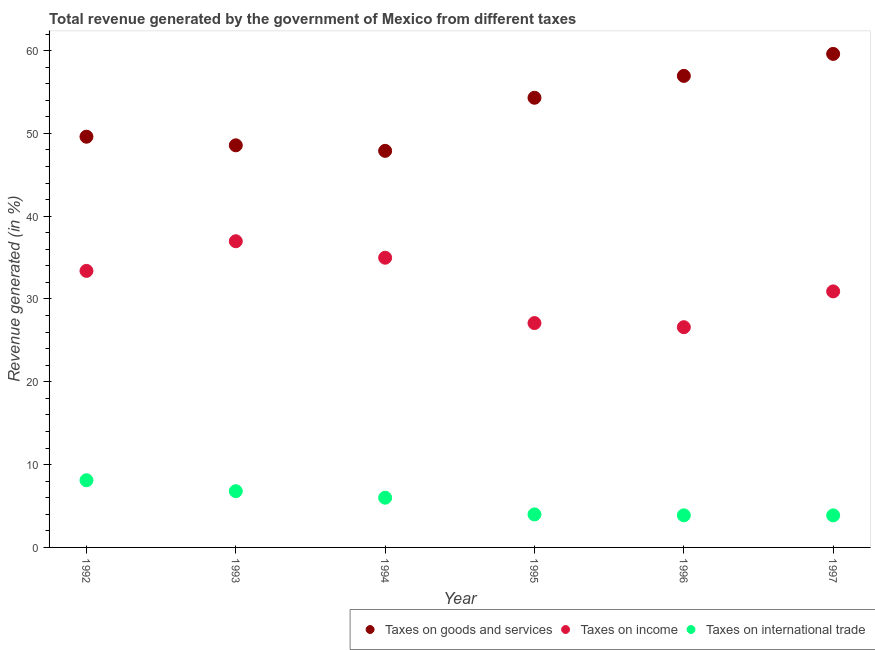How many different coloured dotlines are there?
Provide a succinct answer. 3. Is the number of dotlines equal to the number of legend labels?
Your answer should be very brief. Yes. What is the percentage of revenue generated by tax on international trade in 1995?
Keep it short and to the point. 3.99. Across all years, what is the maximum percentage of revenue generated by taxes on income?
Provide a short and direct response. 36.97. Across all years, what is the minimum percentage of revenue generated by tax on international trade?
Provide a short and direct response. 3.87. In which year was the percentage of revenue generated by taxes on goods and services maximum?
Make the answer very short. 1997. In which year was the percentage of revenue generated by taxes on income minimum?
Ensure brevity in your answer.  1996. What is the total percentage of revenue generated by taxes on goods and services in the graph?
Keep it short and to the point. 316.88. What is the difference between the percentage of revenue generated by tax on international trade in 1992 and that in 1993?
Your response must be concise. 1.32. What is the difference between the percentage of revenue generated by taxes on goods and services in 1994 and the percentage of revenue generated by tax on international trade in 1993?
Provide a short and direct response. 41.1. What is the average percentage of revenue generated by tax on international trade per year?
Your answer should be compact. 5.44. In the year 1992, what is the difference between the percentage of revenue generated by tax on international trade and percentage of revenue generated by taxes on goods and services?
Make the answer very short. -41.49. What is the ratio of the percentage of revenue generated by tax on international trade in 1995 to that in 1996?
Give a very brief answer. 1.03. What is the difference between the highest and the second highest percentage of revenue generated by tax on international trade?
Keep it short and to the point. 1.32. What is the difference between the highest and the lowest percentage of revenue generated by taxes on goods and services?
Your answer should be compact. 11.71. Is it the case that in every year, the sum of the percentage of revenue generated by taxes on goods and services and percentage of revenue generated by taxes on income is greater than the percentage of revenue generated by tax on international trade?
Your answer should be compact. Yes. Is the percentage of revenue generated by tax on international trade strictly greater than the percentage of revenue generated by taxes on income over the years?
Offer a very short reply. No. Is the percentage of revenue generated by taxes on goods and services strictly less than the percentage of revenue generated by tax on international trade over the years?
Your answer should be very brief. No. What is the difference between two consecutive major ticks on the Y-axis?
Offer a terse response. 10. Where does the legend appear in the graph?
Provide a succinct answer. Bottom right. How are the legend labels stacked?
Your answer should be compact. Horizontal. What is the title of the graph?
Provide a short and direct response. Total revenue generated by the government of Mexico from different taxes. Does "Primary" appear as one of the legend labels in the graph?
Keep it short and to the point. No. What is the label or title of the X-axis?
Provide a succinct answer. Year. What is the label or title of the Y-axis?
Your answer should be very brief. Revenue generated (in %). What is the Revenue generated (in %) in Taxes on goods and services in 1992?
Ensure brevity in your answer.  49.6. What is the Revenue generated (in %) in Taxes on income in 1992?
Your response must be concise. 33.4. What is the Revenue generated (in %) in Taxes on international trade in 1992?
Give a very brief answer. 8.11. What is the Revenue generated (in %) of Taxes on goods and services in 1993?
Keep it short and to the point. 48.56. What is the Revenue generated (in %) of Taxes on income in 1993?
Your answer should be very brief. 36.97. What is the Revenue generated (in %) of Taxes on international trade in 1993?
Keep it short and to the point. 6.79. What is the Revenue generated (in %) in Taxes on goods and services in 1994?
Offer a terse response. 47.89. What is the Revenue generated (in %) of Taxes on income in 1994?
Your answer should be compact. 34.98. What is the Revenue generated (in %) in Taxes on international trade in 1994?
Make the answer very short. 6. What is the Revenue generated (in %) of Taxes on goods and services in 1995?
Offer a very short reply. 54.3. What is the Revenue generated (in %) in Taxes on income in 1995?
Your answer should be compact. 27.09. What is the Revenue generated (in %) in Taxes on international trade in 1995?
Keep it short and to the point. 3.99. What is the Revenue generated (in %) of Taxes on goods and services in 1996?
Your answer should be compact. 56.94. What is the Revenue generated (in %) in Taxes on income in 1996?
Ensure brevity in your answer.  26.59. What is the Revenue generated (in %) of Taxes on international trade in 1996?
Give a very brief answer. 3.88. What is the Revenue generated (in %) of Taxes on goods and services in 1997?
Give a very brief answer. 59.6. What is the Revenue generated (in %) in Taxes on income in 1997?
Your answer should be very brief. 30.92. What is the Revenue generated (in %) in Taxes on international trade in 1997?
Ensure brevity in your answer.  3.87. Across all years, what is the maximum Revenue generated (in %) in Taxes on goods and services?
Make the answer very short. 59.6. Across all years, what is the maximum Revenue generated (in %) in Taxes on income?
Ensure brevity in your answer.  36.97. Across all years, what is the maximum Revenue generated (in %) in Taxes on international trade?
Make the answer very short. 8.11. Across all years, what is the minimum Revenue generated (in %) in Taxes on goods and services?
Provide a short and direct response. 47.89. Across all years, what is the minimum Revenue generated (in %) in Taxes on income?
Give a very brief answer. 26.59. Across all years, what is the minimum Revenue generated (in %) of Taxes on international trade?
Your answer should be very brief. 3.87. What is the total Revenue generated (in %) of Taxes on goods and services in the graph?
Make the answer very short. 316.88. What is the total Revenue generated (in %) of Taxes on income in the graph?
Give a very brief answer. 189.96. What is the total Revenue generated (in %) in Taxes on international trade in the graph?
Keep it short and to the point. 32.64. What is the difference between the Revenue generated (in %) of Taxes on goods and services in 1992 and that in 1993?
Ensure brevity in your answer.  1.04. What is the difference between the Revenue generated (in %) of Taxes on income in 1992 and that in 1993?
Keep it short and to the point. -3.58. What is the difference between the Revenue generated (in %) in Taxes on international trade in 1992 and that in 1993?
Your answer should be compact. 1.32. What is the difference between the Revenue generated (in %) in Taxes on goods and services in 1992 and that in 1994?
Provide a succinct answer. 1.71. What is the difference between the Revenue generated (in %) in Taxes on income in 1992 and that in 1994?
Give a very brief answer. -1.59. What is the difference between the Revenue generated (in %) in Taxes on international trade in 1992 and that in 1994?
Offer a terse response. 2.11. What is the difference between the Revenue generated (in %) of Taxes on goods and services in 1992 and that in 1995?
Your answer should be very brief. -4.7. What is the difference between the Revenue generated (in %) in Taxes on income in 1992 and that in 1995?
Your answer should be very brief. 6.3. What is the difference between the Revenue generated (in %) in Taxes on international trade in 1992 and that in 1995?
Your answer should be compact. 4.12. What is the difference between the Revenue generated (in %) in Taxes on goods and services in 1992 and that in 1996?
Provide a succinct answer. -7.34. What is the difference between the Revenue generated (in %) in Taxes on income in 1992 and that in 1996?
Your answer should be compact. 6.8. What is the difference between the Revenue generated (in %) of Taxes on international trade in 1992 and that in 1996?
Provide a short and direct response. 4.23. What is the difference between the Revenue generated (in %) in Taxes on goods and services in 1992 and that in 1997?
Provide a short and direct response. -10. What is the difference between the Revenue generated (in %) of Taxes on income in 1992 and that in 1997?
Provide a succinct answer. 2.48. What is the difference between the Revenue generated (in %) in Taxes on international trade in 1992 and that in 1997?
Offer a terse response. 4.24. What is the difference between the Revenue generated (in %) in Taxes on goods and services in 1993 and that in 1994?
Your answer should be compact. 0.67. What is the difference between the Revenue generated (in %) in Taxes on income in 1993 and that in 1994?
Give a very brief answer. 1.99. What is the difference between the Revenue generated (in %) in Taxes on international trade in 1993 and that in 1994?
Offer a very short reply. 0.79. What is the difference between the Revenue generated (in %) in Taxes on goods and services in 1993 and that in 1995?
Provide a short and direct response. -5.74. What is the difference between the Revenue generated (in %) in Taxes on income in 1993 and that in 1995?
Your answer should be very brief. 9.88. What is the difference between the Revenue generated (in %) of Taxes on international trade in 1993 and that in 1995?
Keep it short and to the point. 2.8. What is the difference between the Revenue generated (in %) in Taxes on goods and services in 1993 and that in 1996?
Ensure brevity in your answer.  -8.38. What is the difference between the Revenue generated (in %) of Taxes on income in 1993 and that in 1996?
Your answer should be very brief. 10.38. What is the difference between the Revenue generated (in %) in Taxes on international trade in 1993 and that in 1996?
Provide a short and direct response. 2.91. What is the difference between the Revenue generated (in %) in Taxes on goods and services in 1993 and that in 1997?
Ensure brevity in your answer.  -11.04. What is the difference between the Revenue generated (in %) in Taxes on income in 1993 and that in 1997?
Your answer should be compact. 6.06. What is the difference between the Revenue generated (in %) in Taxes on international trade in 1993 and that in 1997?
Your answer should be very brief. 2.92. What is the difference between the Revenue generated (in %) of Taxes on goods and services in 1994 and that in 1995?
Ensure brevity in your answer.  -6.41. What is the difference between the Revenue generated (in %) in Taxes on income in 1994 and that in 1995?
Make the answer very short. 7.89. What is the difference between the Revenue generated (in %) in Taxes on international trade in 1994 and that in 1995?
Ensure brevity in your answer.  2.02. What is the difference between the Revenue generated (in %) in Taxes on goods and services in 1994 and that in 1996?
Keep it short and to the point. -9.05. What is the difference between the Revenue generated (in %) of Taxes on income in 1994 and that in 1996?
Provide a short and direct response. 8.39. What is the difference between the Revenue generated (in %) in Taxes on international trade in 1994 and that in 1996?
Give a very brief answer. 2.13. What is the difference between the Revenue generated (in %) of Taxes on goods and services in 1994 and that in 1997?
Offer a very short reply. -11.71. What is the difference between the Revenue generated (in %) of Taxes on income in 1994 and that in 1997?
Your answer should be compact. 4.07. What is the difference between the Revenue generated (in %) of Taxes on international trade in 1994 and that in 1997?
Your answer should be very brief. 2.13. What is the difference between the Revenue generated (in %) of Taxes on goods and services in 1995 and that in 1996?
Keep it short and to the point. -2.64. What is the difference between the Revenue generated (in %) of Taxes on income in 1995 and that in 1996?
Your response must be concise. 0.5. What is the difference between the Revenue generated (in %) of Taxes on international trade in 1995 and that in 1996?
Offer a very short reply. 0.11. What is the difference between the Revenue generated (in %) of Taxes on goods and services in 1995 and that in 1997?
Offer a terse response. -5.3. What is the difference between the Revenue generated (in %) in Taxes on income in 1995 and that in 1997?
Provide a succinct answer. -3.82. What is the difference between the Revenue generated (in %) of Taxes on international trade in 1995 and that in 1997?
Make the answer very short. 0.12. What is the difference between the Revenue generated (in %) of Taxes on goods and services in 1996 and that in 1997?
Provide a short and direct response. -2.66. What is the difference between the Revenue generated (in %) of Taxes on income in 1996 and that in 1997?
Keep it short and to the point. -4.32. What is the difference between the Revenue generated (in %) of Taxes on international trade in 1996 and that in 1997?
Provide a short and direct response. 0.01. What is the difference between the Revenue generated (in %) of Taxes on goods and services in 1992 and the Revenue generated (in %) of Taxes on income in 1993?
Provide a succinct answer. 12.62. What is the difference between the Revenue generated (in %) of Taxes on goods and services in 1992 and the Revenue generated (in %) of Taxes on international trade in 1993?
Provide a succinct answer. 42.81. What is the difference between the Revenue generated (in %) of Taxes on income in 1992 and the Revenue generated (in %) of Taxes on international trade in 1993?
Your answer should be compact. 26.6. What is the difference between the Revenue generated (in %) of Taxes on goods and services in 1992 and the Revenue generated (in %) of Taxes on income in 1994?
Offer a terse response. 14.61. What is the difference between the Revenue generated (in %) in Taxes on goods and services in 1992 and the Revenue generated (in %) in Taxes on international trade in 1994?
Offer a very short reply. 43.59. What is the difference between the Revenue generated (in %) in Taxes on income in 1992 and the Revenue generated (in %) in Taxes on international trade in 1994?
Ensure brevity in your answer.  27.39. What is the difference between the Revenue generated (in %) in Taxes on goods and services in 1992 and the Revenue generated (in %) in Taxes on income in 1995?
Make the answer very short. 22.5. What is the difference between the Revenue generated (in %) of Taxes on goods and services in 1992 and the Revenue generated (in %) of Taxes on international trade in 1995?
Provide a succinct answer. 45.61. What is the difference between the Revenue generated (in %) of Taxes on income in 1992 and the Revenue generated (in %) of Taxes on international trade in 1995?
Give a very brief answer. 29.41. What is the difference between the Revenue generated (in %) in Taxes on goods and services in 1992 and the Revenue generated (in %) in Taxes on income in 1996?
Keep it short and to the point. 23. What is the difference between the Revenue generated (in %) in Taxes on goods and services in 1992 and the Revenue generated (in %) in Taxes on international trade in 1996?
Provide a succinct answer. 45.72. What is the difference between the Revenue generated (in %) of Taxes on income in 1992 and the Revenue generated (in %) of Taxes on international trade in 1996?
Your answer should be compact. 29.52. What is the difference between the Revenue generated (in %) of Taxes on goods and services in 1992 and the Revenue generated (in %) of Taxes on income in 1997?
Ensure brevity in your answer.  18.68. What is the difference between the Revenue generated (in %) in Taxes on goods and services in 1992 and the Revenue generated (in %) in Taxes on international trade in 1997?
Your response must be concise. 45.73. What is the difference between the Revenue generated (in %) in Taxes on income in 1992 and the Revenue generated (in %) in Taxes on international trade in 1997?
Give a very brief answer. 29.52. What is the difference between the Revenue generated (in %) of Taxes on goods and services in 1993 and the Revenue generated (in %) of Taxes on income in 1994?
Ensure brevity in your answer.  13.57. What is the difference between the Revenue generated (in %) in Taxes on goods and services in 1993 and the Revenue generated (in %) in Taxes on international trade in 1994?
Ensure brevity in your answer.  42.55. What is the difference between the Revenue generated (in %) of Taxes on income in 1993 and the Revenue generated (in %) of Taxes on international trade in 1994?
Ensure brevity in your answer.  30.97. What is the difference between the Revenue generated (in %) of Taxes on goods and services in 1993 and the Revenue generated (in %) of Taxes on income in 1995?
Offer a very short reply. 21.46. What is the difference between the Revenue generated (in %) in Taxes on goods and services in 1993 and the Revenue generated (in %) in Taxes on international trade in 1995?
Offer a terse response. 44.57. What is the difference between the Revenue generated (in %) in Taxes on income in 1993 and the Revenue generated (in %) in Taxes on international trade in 1995?
Provide a succinct answer. 32.99. What is the difference between the Revenue generated (in %) of Taxes on goods and services in 1993 and the Revenue generated (in %) of Taxes on income in 1996?
Give a very brief answer. 21.96. What is the difference between the Revenue generated (in %) of Taxes on goods and services in 1993 and the Revenue generated (in %) of Taxes on international trade in 1996?
Offer a terse response. 44.68. What is the difference between the Revenue generated (in %) in Taxes on income in 1993 and the Revenue generated (in %) in Taxes on international trade in 1996?
Provide a short and direct response. 33.1. What is the difference between the Revenue generated (in %) in Taxes on goods and services in 1993 and the Revenue generated (in %) in Taxes on income in 1997?
Your answer should be compact. 17.64. What is the difference between the Revenue generated (in %) in Taxes on goods and services in 1993 and the Revenue generated (in %) in Taxes on international trade in 1997?
Offer a terse response. 44.69. What is the difference between the Revenue generated (in %) in Taxes on income in 1993 and the Revenue generated (in %) in Taxes on international trade in 1997?
Offer a terse response. 33.1. What is the difference between the Revenue generated (in %) of Taxes on goods and services in 1994 and the Revenue generated (in %) of Taxes on income in 1995?
Your answer should be compact. 20.8. What is the difference between the Revenue generated (in %) of Taxes on goods and services in 1994 and the Revenue generated (in %) of Taxes on international trade in 1995?
Provide a succinct answer. 43.9. What is the difference between the Revenue generated (in %) of Taxes on income in 1994 and the Revenue generated (in %) of Taxes on international trade in 1995?
Provide a succinct answer. 31. What is the difference between the Revenue generated (in %) in Taxes on goods and services in 1994 and the Revenue generated (in %) in Taxes on income in 1996?
Provide a succinct answer. 21.29. What is the difference between the Revenue generated (in %) in Taxes on goods and services in 1994 and the Revenue generated (in %) in Taxes on international trade in 1996?
Your answer should be compact. 44.01. What is the difference between the Revenue generated (in %) of Taxes on income in 1994 and the Revenue generated (in %) of Taxes on international trade in 1996?
Your response must be concise. 31.11. What is the difference between the Revenue generated (in %) of Taxes on goods and services in 1994 and the Revenue generated (in %) of Taxes on income in 1997?
Offer a very short reply. 16.97. What is the difference between the Revenue generated (in %) of Taxes on goods and services in 1994 and the Revenue generated (in %) of Taxes on international trade in 1997?
Ensure brevity in your answer.  44.02. What is the difference between the Revenue generated (in %) in Taxes on income in 1994 and the Revenue generated (in %) in Taxes on international trade in 1997?
Provide a short and direct response. 31.11. What is the difference between the Revenue generated (in %) in Taxes on goods and services in 1995 and the Revenue generated (in %) in Taxes on income in 1996?
Your answer should be very brief. 27.71. What is the difference between the Revenue generated (in %) of Taxes on goods and services in 1995 and the Revenue generated (in %) of Taxes on international trade in 1996?
Make the answer very short. 50.42. What is the difference between the Revenue generated (in %) of Taxes on income in 1995 and the Revenue generated (in %) of Taxes on international trade in 1996?
Keep it short and to the point. 23.22. What is the difference between the Revenue generated (in %) of Taxes on goods and services in 1995 and the Revenue generated (in %) of Taxes on income in 1997?
Your answer should be very brief. 23.38. What is the difference between the Revenue generated (in %) in Taxes on goods and services in 1995 and the Revenue generated (in %) in Taxes on international trade in 1997?
Offer a very short reply. 50.43. What is the difference between the Revenue generated (in %) in Taxes on income in 1995 and the Revenue generated (in %) in Taxes on international trade in 1997?
Offer a very short reply. 23.22. What is the difference between the Revenue generated (in %) of Taxes on goods and services in 1996 and the Revenue generated (in %) of Taxes on income in 1997?
Keep it short and to the point. 26.02. What is the difference between the Revenue generated (in %) in Taxes on goods and services in 1996 and the Revenue generated (in %) in Taxes on international trade in 1997?
Your answer should be compact. 53.07. What is the difference between the Revenue generated (in %) in Taxes on income in 1996 and the Revenue generated (in %) in Taxes on international trade in 1997?
Your answer should be compact. 22.72. What is the average Revenue generated (in %) in Taxes on goods and services per year?
Give a very brief answer. 52.81. What is the average Revenue generated (in %) in Taxes on income per year?
Give a very brief answer. 31.66. What is the average Revenue generated (in %) of Taxes on international trade per year?
Offer a terse response. 5.44. In the year 1992, what is the difference between the Revenue generated (in %) of Taxes on goods and services and Revenue generated (in %) of Taxes on income?
Give a very brief answer. 16.2. In the year 1992, what is the difference between the Revenue generated (in %) in Taxes on goods and services and Revenue generated (in %) in Taxes on international trade?
Ensure brevity in your answer.  41.49. In the year 1992, what is the difference between the Revenue generated (in %) of Taxes on income and Revenue generated (in %) of Taxes on international trade?
Ensure brevity in your answer.  25.28. In the year 1993, what is the difference between the Revenue generated (in %) in Taxes on goods and services and Revenue generated (in %) in Taxes on income?
Give a very brief answer. 11.58. In the year 1993, what is the difference between the Revenue generated (in %) of Taxes on goods and services and Revenue generated (in %) of Taxes on international trade?
Ensure brevity in your answer.  41.77. In the year 1993, what is the difference between the Revenue generated (in %) in Taxes on income and Revenue generated (in %) in Taxes on international trade?
Give a very brief answer. 30.18. In the year 1994, what is the difference between the Revenue generated (in %) of Taxes on goods and services and Revenue generated (in %) of Taxes on income?
Keep it short and to the point. 12.9. In the year 1994, what is the difference between the Revenue generated (in %) in Taxes on goods and services and Revenue generated (in %) in Taxes on international trade?
Make the answer very short. 41.88. In the year 1994, what is the difference between the Revenue generated (in %) in Taxes on income and Revenue generated (in %) in Taxes on international trade?
Offer a very short reply. 28.98. In the year 1995, what is the difference between the Revenue generated (in %) in Taxes on goods and services and Revenue generated (in %) in Taxes on income?
Keep it short and to the point. 27.21. In the year 1995, what is the difference between the Revenue generated (in %) of Taxes on goods and services and Revenue generated (in %) of Taxes on international trade?
Offer a terse response. 50.31. In the year 1995, what is the difference between the Revenue generated (in %) of Taxes on income and Revenue generated (in %) of Taxes on international trade?
Ensure brevity in your answer.  23.11. In the year 1996, what is the difference between the Revenue generated (in %) in Taxes on goods and services and Revenue generated (in %) in Taxes on income?
Offer a terse response. 30.35. In the year 1996, what is the difference between the Revenue generated (in %) in Taxes on goods and services and Revenue generated (in %) in Taxes on international trade?
Keep it short and to the point. 53.06. In the year 1996, what is the difference between the Revenue generated (in %) of Taxes on income and Revenue generated (in %) of Taxes on international trade?
Provide a succinct answer. 22.72. In the year 1997, what is the difference between the Revenue generated (in %) of Taxes on goods and services and Revenue generated (in %) of Taxes on income?
Provide a succinct answer. 28.68. In the year 1997, what is the difference between the Revenue generated (in %) of Taxes on goods and services and Revenue generated (in %) of Taxes on international trade?
Your answer should be compact. 55.73. In the year 1997, what is the difference between the Revenue generated (in %) in Taxes on income and Revenue generated (in %) in Taxes on international trade?
Ensure brevity in your answer.  27.05. What is the ratio of the Revenue generated (in %) of Taxes on goods and services in 1992 to that in 1993?
Your response must be concise. 1.02. What is the ratio of the Revenue generated (in %) in Taxes on income in 1992 to that in 1993?
Make the answer very short. 0.9. What is the ratio of the Revenue generated (in %) of Taxes on international trade in 1992 to that in 1993?
Ensure brevity in your answer.  1.19. What is the ratio of the Revenue generated (in %) in Taxes on goods and services in 1992 to that in 1994?
Ensure brevity in your answer.  1.04. What is the ratio of the Revenue generated (in %) of Taxes on income in 1992 to that in 1994?
Your response must be concise. 0.95. What is the ratio of the Revenue generated (in %) in Taxes on international trade in 1992 to that in 1994?
Offer a terse response. 1.35. What is the ratio of the Revenue generated (in %) in Taxes on goods and services in 1992 to that in 1995?
Make the answer very short. 0.91. What is the ratio of the Revenue generated (in %) of Taxes on income in 1992 to that in 1995?
Your response must be concise. 1.23. What is the ratio of the Revenue generated (in %) of Taxes on international trade in 1992 to that in 1995?
Provide a succinct answer. 2.03. What is the ratio of the Revenue generated (in %) of Taxes on goods and services in 1992 to that in 1996?
Offer a terse response. 0.87. What is the ratio of the Revenue generated (in %) in Taxes on income in 1992 to that in 1996?
Ensure brevity in your answer.  1.26. What is the ratio of the Revenue generated (in %) of Taxes on international trade in 1992 to that in 1996?
Your answer should be compact. 2.09. What is the ratio of the Revenue generated (in %) of Taxes on goods and services in 1992 to that in 1997?
Your answer should be very brief. 0.83. What is the ratio of the Revenue generated (in %) in Taxes on income in 1992 to that in 1997?
Offer a very short reply. 1.08. What is the ratio of the Revenue generated (in %) of Taxes on international trade in 1992 to that in 1997?
Your response must be concise. 2.1. What is the ratio of the Revenue generated (in %) in Taxes on income in 1993 to that in 1994?
Give a very brief answer. 1.06. What is the ratio of the Revenue generated (in %) of Taxes on international trade in 1993 to that in 1994?
Your answer should be compact. 1.13. What is the ratio of the Revenue generated (in %) in Taxes on goods and services in 1993 to that in 1995?
Your response must be concise. 0.89. What is the ratio of the Revenue generated (in %) of Taxes on income in 1993 to that in 1995?
Provide a short and direct response. 1.36. What is the ratio of the Revenue generated (in %) of Taxes on international trade in 1993 to that in 1995?
Give a very brief answer. 1.7. What is the ratio of the Revenue generated (in %) of Taxes on goods and services in 1993 to that in 1996?
Make the answer very short. 0.85. What is the ratio of the Revenue generated (in %) of Taxes on income in 1993 to that in 1996?
Ensure brevity in your answer.  1.39. What is the ratio of the Revenue generated (in %) of Taxes on international trade in 1993 to that in 1996?
Offer a very short reply. 1.75. What is the ratio of the Revenue generated (in %) of Taxes on goods and services in 1993 to that in 1997?
Give a very brief answer. 0.81. What is the ratio of the Revenue generated (in %) in Taxes on income in 1993 to that in 1997?
Ensure brevity in your answer.  1.2. What is the ratio of the Revenue generated (in %) of Taxes on international trade in 1993 to that in 1997?
Keep it short and to the point. 1.75. What is the ratio of the Revenue generated (in %) in Taxes on goods and services in 1994 to that in 1995?
Provide a succinct answer. 0.88. What is the ratio of the Revenue generated (in %) of Taxes on income in 1994 to that in 1995?
Offer a terse response. 1.29. What is the ratio of the Revenue generated (in %) in Taxes on international trade in 1994 to that in 1995?
Offer a very short reply. 1.51. What is the ratio of the Revenue generated (in %) in Taxes on goods and services in 1994 to that in 1996?
Offer a very short reply. 0.84. What is the ratio of the Revenue generated (in %) in Taxes on income in 1994 to that in 1996?
Your answer should be very brief. 1.32. What is the ratio of the Revenue generated (in %) of Taxes on international trade in 1994 to that in 1996?
Make the answer very short. 1.55. What is the ratio of the Revenue generated (in %) in Taxes on goods and services in 1994 to that in 1997?
Offer a very short reply. 0.8. What is the ratio of the Revenue generated (in %) in Taxes on income in 1994 to that in 1997?
Offer a very short reply. 1.13. What is the ratio of the Revenue generated (in %) of Taxes on international trade in 1994 to that in 1997?
Give a very brief answer. 1.55. What is the ratio of the Revenue generated (in %) in Taxes on goods and services in 1995 to that in 1996?
Offer a terse response. 0.95. What is the ratio of the Revenue generated (in %) of Taxes on income in 1995 to that in 1996?
Provide a short and direct response. 1.02. What is the ratio of the Revenue generated (in %) of Taxes on international trade in 1995 to that in 1996?
Give a very brief answer. 1.03. What is the ratio of the Revenue generated (in %) in Taxes on goods and services in 1995 to that in 1997?
Ensure brevity in your answer.  0.91. What is the ratio of the Revenue generated (in %) of Taxes on income in 1995 to that in 1997?
Ensure brevity in your answer.  0.88. What is the ratio of the Revenue generated (in %) in Taxes on international trade in 1995 to that in 1997?
Give a very brief answer. 1.03. What is the ratio of the Revenue generated (in %) of Taxes on goods and services in 1996 to that in 1997?
Keep it short and to the point. 0.96. What is the ratio of the Revenue generated (in %) of Taxes on income in 1996 to that in 1997?
Your answer should be very brief. 0.86. What is the ratio of the Revenue generated (in %) in Taxes on international trade in 1996 to that in 1997?
Your answer should be compact. 1. What is the difference between the highest and the second highest Revenue generated (in %) in Taxes on goods and services?
Provide a succinct answer. 2.66. What is the difference between the highest and the second highest Revenue generated (in %) of Taxes on income?
Offer a terse response. 1.99. What is the difference between the highest and the second highest Revenue generated (in %) in Taxes on international trade?
Offer a terse response. 1.32. What is the difference between the highest and the lowest Revenue generated (in %) of Taxes on goods and services?
Offer a terse response. 11.71. What is the difference between the highest and the lowest Revenue generated (in %) of Taxes on income?
Provide a short and direct response. 10.38. What is the difference between the highest and the lowest Revenue generated (in %) of Taxes on international trade?
Your answer should be compact. 4.24. 